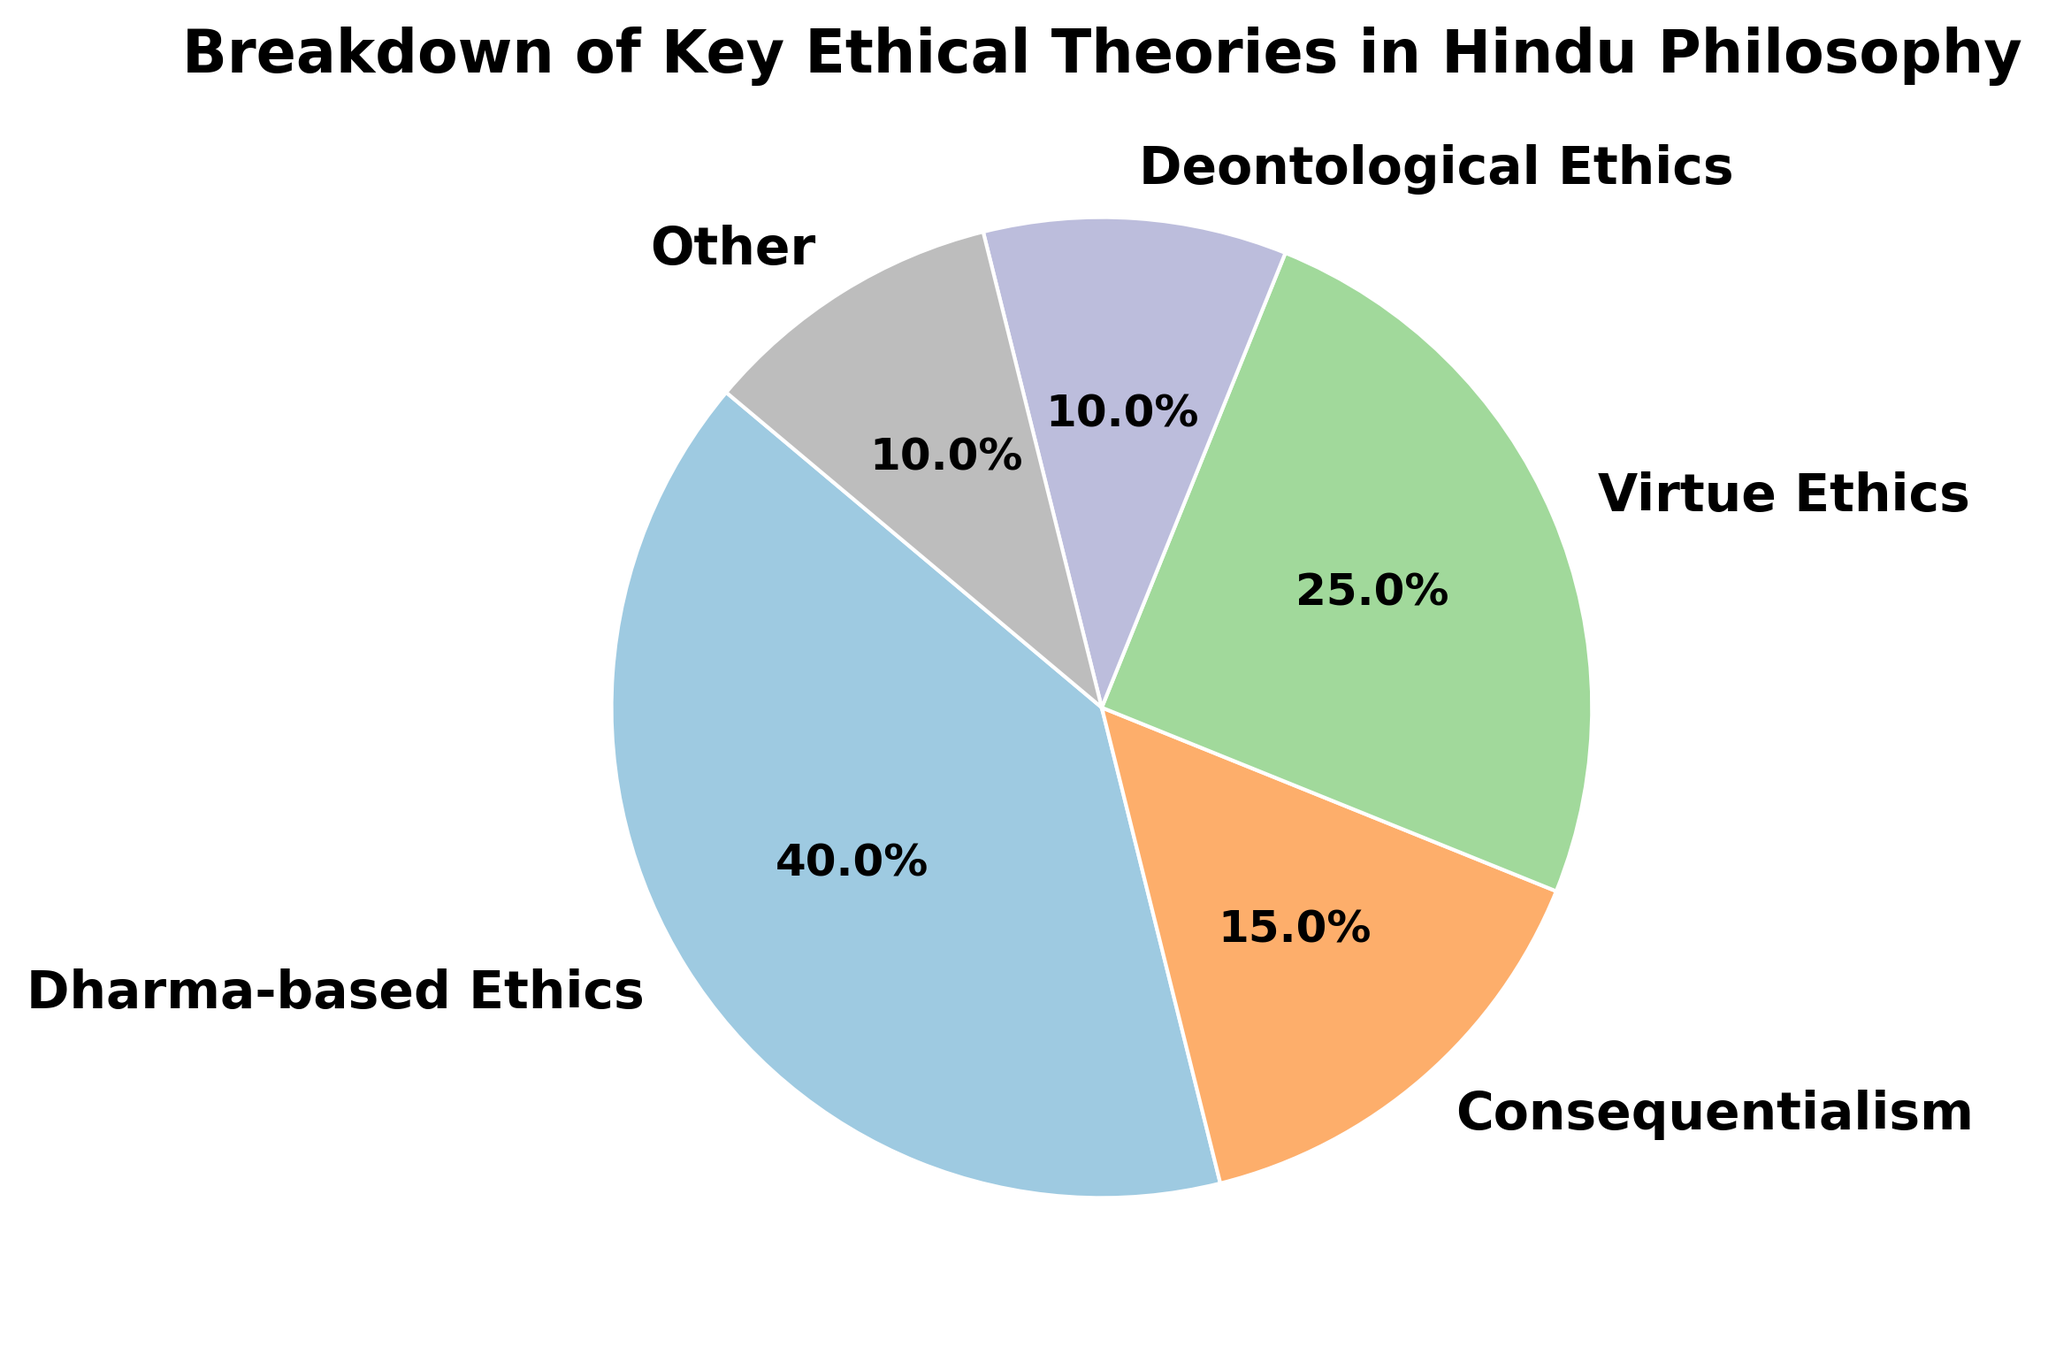Which ethical theory has the largest percentage? By examining the slices of the pie chart, `Dharma-based Ethics` is the largest segment. It occupies a bigger portion of the pie chart compared to other segments, representing 40%.
Answer: Dharma-based Ethics How much larger is Dharma-based Ethics compared to Consequentialism? The percentage for Dharma-based Ethics is 40%, and for Consequentialism, it is 15%. The difference between them is calculated as 40% - 15% = 25%.
Answer: 25% Which two ethical theories have the same percentage? By examining the pie chart, `Deontological Ethics` and `Other` each occupy equal slices, both representing 10% of the chart.
Answer: Deontological Ethics and Other What is the combined percentage of Virtue Ethics and Consequentialism? The percentage of Virtue Ethics is 25%, and for Consequentialism, it is 15%. Adding these two values results in 25% + 15% = 40%.
Answer: 40% Which ethical theory has the smallest percentage? By examining the smallest slices in the pie chart, both `Deontological Ethics` and `Other` have the smallest percentages, each occupying 10%.
Answer: Deontological Ethics and Other What is the total percentage of all ethical theories excluding Dharma-based Ethics? Excluding Dharma-based Ethics (40%), the sum of the remaining percentages is 15% (Consequentialism) + 25% (Virtue Ethics) + 10% (Deontological Ethics) + 10% (Other) = 60%.
Answer: 60% Which segment is visually represented in a light green color? By identifying the colors used in the pie chart, `Virtue Ethics` is visually represented in light green.
Answer: Virtue Ethics How many ethical theories hold a percentage greater than 20%? By observing the sizes of the pie chart segments, only `Dharma-based Ethics` (40%) and `Virtue Ethics` (25%) have percentages greater than 20%. Hence, two ethical theories meet this criterion.
Answer: 2 